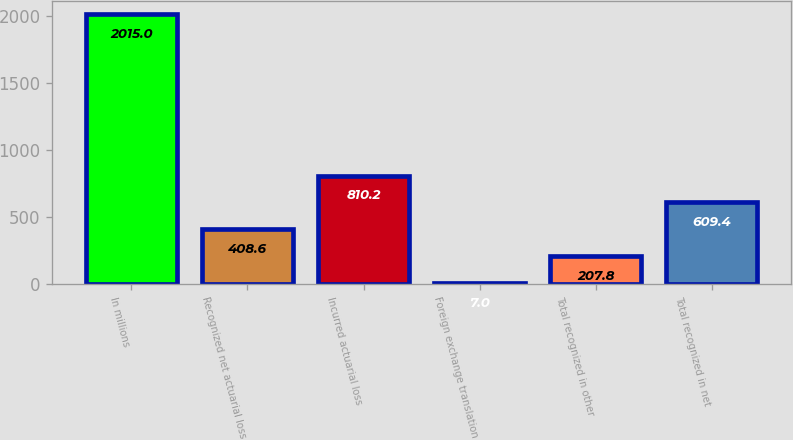Convert chart. <chart><loc_0><loc_0><loc_500><loc_500><bar_chart><fcel>In millions<fcel>Recognized net actuarial loss<fcel>Incurred actuarial loss<fcel>Foreign exchange translation<fcel>Total recognized in other<fcel>Total recognized in net<nl><fcel>2015<fcel>408.6<fcel>810.2<fcel>7<fcel>207.8<fcel>609.4<nl></chart> 